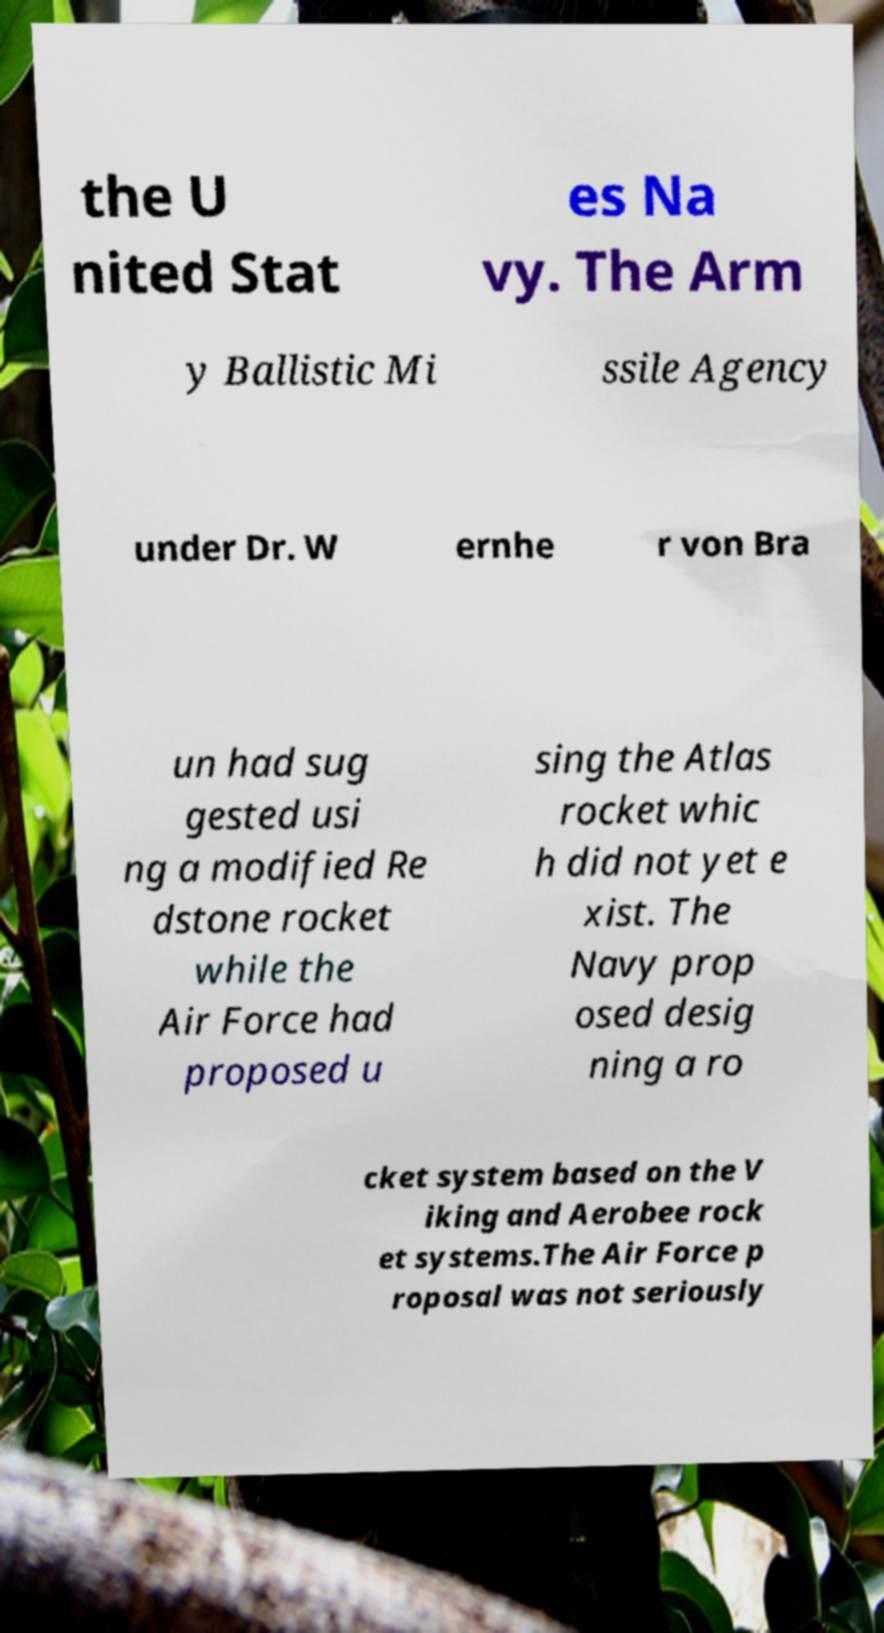Please read and relay the text visible in this image. What does it say? the U nited Stat es Na vy. The Arm y Ballistic Mi ssile Agency under Dr. W ernhe r von Bra un had sug gested usi ng a modified Re dstone rocket while the Air Force had proposed u sing the Atlas rocket whic h did not yet e xist. The Navy prop osed desig ning a ro cket system based on the V iking and Aerobee rock et systems.The Air Force p roposal was not seriously 